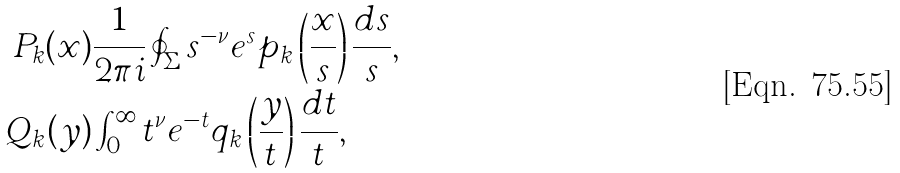Convert formula to latex. <formula><loc_0><loc_0><loc_500><loc_500>P _ { k } ( x ) & \frac { 1 } { 2 \pi i } \oint _ { \Sigma } s ^ { - \nu } e ^ { s } p _ { k } \left ( \frac { x } { s } \right ) \frac { d s } { s } , \\ Q _ { k } ( y ) & \int _ { 0 } ^ { \infty } t ^ { \nu } e ^ { - t } q _ { k } \left ( \frac { y } { t } \right ) \frac { d t } { t } ,</formula> 